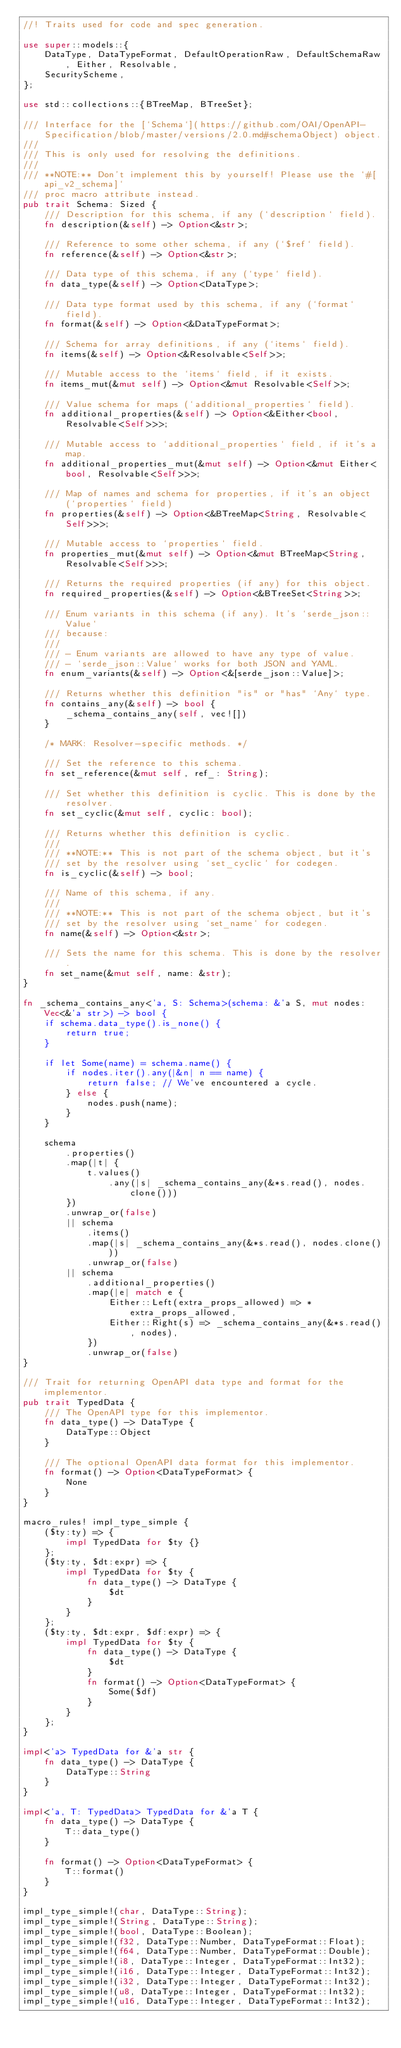Convert code to text. <code><loc_0><loc_0><loc_500><loc_500><_Rust_>//! Traits used for code and spec generation.

use super::models::{
    DataType, DataTypeFormat, DefaultOperationRaw, DefaultSchemaRaw, Either, Resolvable,
    SecurityScheme,
};

use std::collections::{BTreeMap, BTreeSet};

/// Interface for the [`Schema`](https://github.com/OAI/OpenAPI-Specification/blob/master/versions/2.0.md#schemaObject) object.
///
/// This is only used for resolving the definitions.
///
/// **NOTE:** Don't implement this by yourself! Please use the `#[api_v2_schema]`
/// proc macro attribute instead.
pub trait Schema: Sized {
    /// Description for this schema, if any (`description` field).
    fn description(&self) -> Option<&str>;

    /// Reference to some other schema, if any (`$ref` field).
    fn reference(&self) -> Option<&str>;

    /// Data type of this schema, if any (`type` field).
    fn data_type(&self) -> Option<DataType>;

    /// Data type format used by this schema, if any (`format` field).
    fn format(&self) -> Option<&DataTypeFormat>;

    /// Schema for array definitions, if any (`items` field).
    fn items(&self) -> Option<&Resolvable<Self>>;

    /// Mutable access to the `items` field, if it exists.
    fn items_mut(&mut self) -> Option<&mut Resolvable<Self>>;

    /// Value schema for maps (`additional_properties` field).
    fn additional_properties(&self) -> Option<&Either<bool, Resolvable<Self>>>;

    /// Mutable access to `additional_properties` field, if it's a map.
    fn additional_properties_mut(&mut self) -> Option<&mut Either<bool, Resolvable<Self>>>;

    /// Map of names and schema for properties, if it's an object (`properties` field)
    fn properties(&self) -> Option<&BTreeMap<String, Resolvable<Self>>>;

    /// Mutable access to `properties` field.
    fn properties_mut(&mut self) -> Option<&mut BTreeMap<String, Resolvable<Self>>>;

    /// Returns the required properties (if any) for this object.
    fn required_properties(&self) -> Option<&BTreeSet<String>>;

    /// Enum variants in this schema (if any). It's `serde_json::Value`
    /// because:
    ///
    /// - Enum variants are allowed to have any type of value.
    /// - `serde_json::Value` works for both JSON and YAML.
    fn enum_variants(&self) -> Option<&[serde_json::Value]>;

    /// Returns whether this definition "is" or "has" `Any` type.
    fn contains_any(&self) -> bool {
        _schema_contains_any(self, vec![])
    }

    /* MARK: Resolver-specific methods. */

    /// Set the reference to this schema.
    fn set_reference(&mut self, ref_: String);

    /// Set whether this definition is cyclic. This is done by the resolver.
    fn set_cyclic(&mut self, cyclic: bool);

    /// Returns whether this definition is cyclic.
    ///
    /// **NOTE:** This is not part of the schema object, but it's
    /// set by the resolver using `set_cyclic` for codegen.
    fn is_cyclic(&self) -> bool;

    /// Name of this schema, if any.
    ///
    /// **NOTE:** This is not part of the schema object, but it's
    /// set by the resolver using `set_name` for codegen.
    fn name(&self) -> Option<&str>;

    /// Sets the name for this schema. This is done by the resolver.
    fn set_name(&mut self, name: &str);
}

fn _schema_contains_any<'a, S: Schema>(schema: &'a S, mut nodes: Vec<&'a str>) -> bool {
    if schema.data_type().is_none() {
        return true;
    }

    if let Some(name) = schema.name() {
        if nodes.iter().any(|&n| n == name) {
            return false; // We've encountered a cycle.
        } else {
            nodes.push(name);
        }
    }

    schema
        .properties()
        .map(|t| {
            t.values()
                .any(|s| _schema_contains_any(&*s.read(), nodes.clone()))
        })
        .unwrap_or(false)
        || schema
            .items()
            .map(|s| _schema_contains_any(&*s.read(), nodes.clone()))
            .unwrap_or(false)
        || schema
            .additional_properties()
            .map(|e| match e {
                Either::Left(extra_props_allowed) => *extra_props_allowed,
                Either::Right(s) => _schema_contains_any(&*s.read(), nodes),
            })
            .unwrap_or(false)
}

/// Trait for returning OpenAPI data type and format for the implementor.
pub trait TypedData {
    /// The OpenAPI type for this implementor.
    fn data_type() -> DataType {
        DataType::Object
    }

    /// The optional OpenAPI data format for this implementor.
    fn format() -> Option<DataTypeFormat> {
        None
    }
}

macro_rules! impl_type_simple {
    ($ty:ty) => {
        impl TypedData for $ty {}
    };
    ($ty:ty, $dt:expr) => {
        impl TypedData for $ty {
            fn data_type() -> DataType {
                $dt
            }
        }
    };
    ($ty:ty, $dt:expr, $df:expr) => {
        impl TypedData for $ty {
            fn data_type() -> DataType {
                $dt
            }
            fn format() -> Option<DataTypeFormat> {
                Some($df)
            }
        }
    };
}

impl<'a> TypedData for &'a str {
    fn data_type() -> DataType {
        DataType::String
    }
}

impl<'a, T: TypedData> TypedData for &'a T {
    fn data_type() -> DataType {
        T::data_type()
    }

    fn format() -> Option<DataTypeFormat> {
        T::format()
    }
}

impl_type_simple!(char, DataType::String);
impl_type_simple!(String, DataType::String);
impl_type_simple!(bool, DataType::Boolean);
impl_type_simple!(f32, DataType::Number, DataTypeFormat::Float);
impl_type_simple!(f64, DataType::Number, DataTypeFormat::Double);
impl_type_simple!(i8, DataType::Integer, DataTypeFormat::Int32);
impl_type_simple!(i16, DataType::Integer, DataTypeFormat::Int32);
impl_type_simple!(i32, DataType::Integer, DataTypeFormat::Int32);
impl_type_simple!(u8, DataType::Integer, DataTypeFormat::Int32);
impl_type_simple!(u16, DataType::Integer, DataTypeFormat::Int32);</code> 